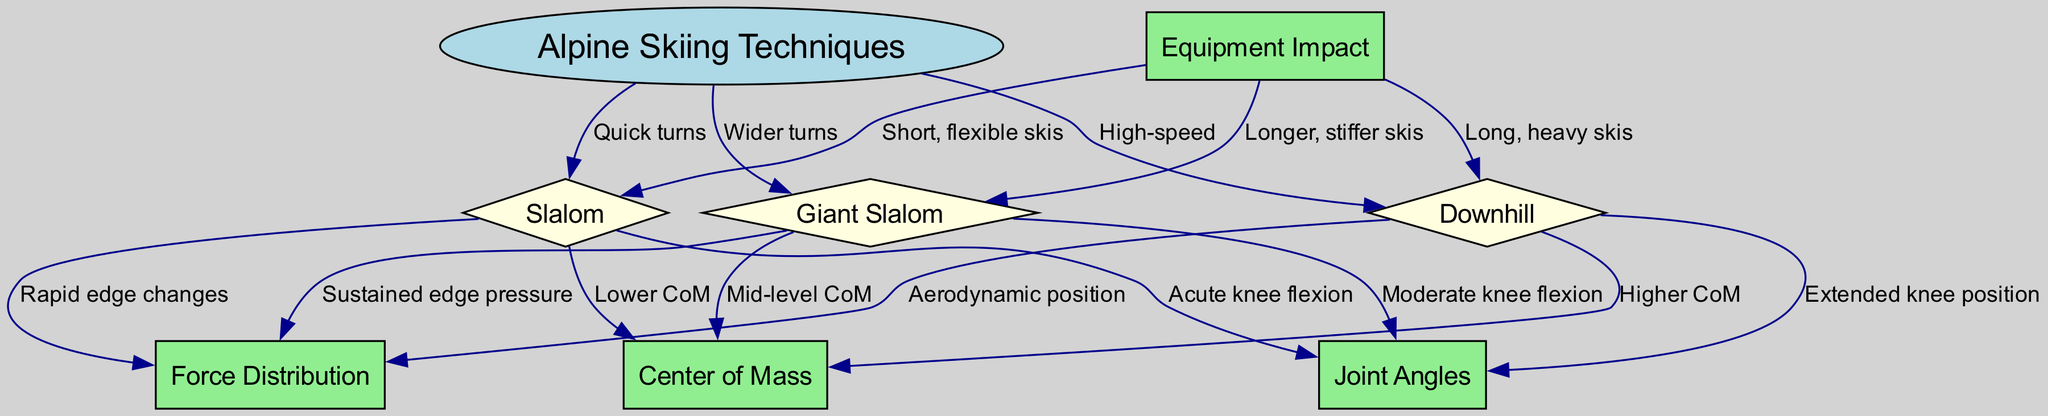What are the three main skiing techniques? The diagram lists the three main skiing techniques under the node "Alpine Skiing Techniques," which includes "Slalom," "Giant Slalom," and "Downhill."
Answer: Slalom, Giant Slalom, Downhill What joint angle is associated with Slalom? The diagram shows an edge from the "Slalom" node to the "Joint Angles" node labeled as "Acute knee flexion," indicating that this technique involves acute knee flexion.
Answer: Acute knee flexion Which skiing technique has the highest center of mass? In the diagram, the "Downhill" technique has an edge to the "Center of Mass" node labeled "Higher CoM," indicating that it has the highest center of mass among the techniques.
Answer: Higher CoM How does Force Distribution differ between Slalom and Downhill? The diagram reveals that Slalom involves "Rapid edge changes," while Downhill involves "Aerodynamic position." Hence, it can be inferred that Force Distribution differs significantly in technique and style between the two.
Answer: Significant difference What type of skis is associated with Slalom? The diagram explicitly connects the "Equipment Impact" node to the "Slalom" node, listing the label as "Short, flexible skis," indicating the specific type of skis used.
Answer: Short, flexible skis What is the force distribution characteristic of Giant Slalom? According to the diagram, Giant Slalom has an edge to the Force Distribution node labeled "Sustained edge pressure," indicating that this technique has a characteristic force distribution.
Answer: Sustained edge pressure How many edges lead from Alpine Skiing Techniques to specific techniques? The diagram presents three edges that connect the "Alpine Skiing Techniques" node to the specific technique nodes: Slalom, Giant Slalom, and Downhill, thus counting three edges in total.
Answer: 3 What type of ski is used in Downhill skiing? As shown in the diagram, the "Equipment Impact" node has a direct edge to the "Downhill" node labeled "Long, heavy skis," specifying the equipment used for this technique.
Answer: Long, heavy skis 